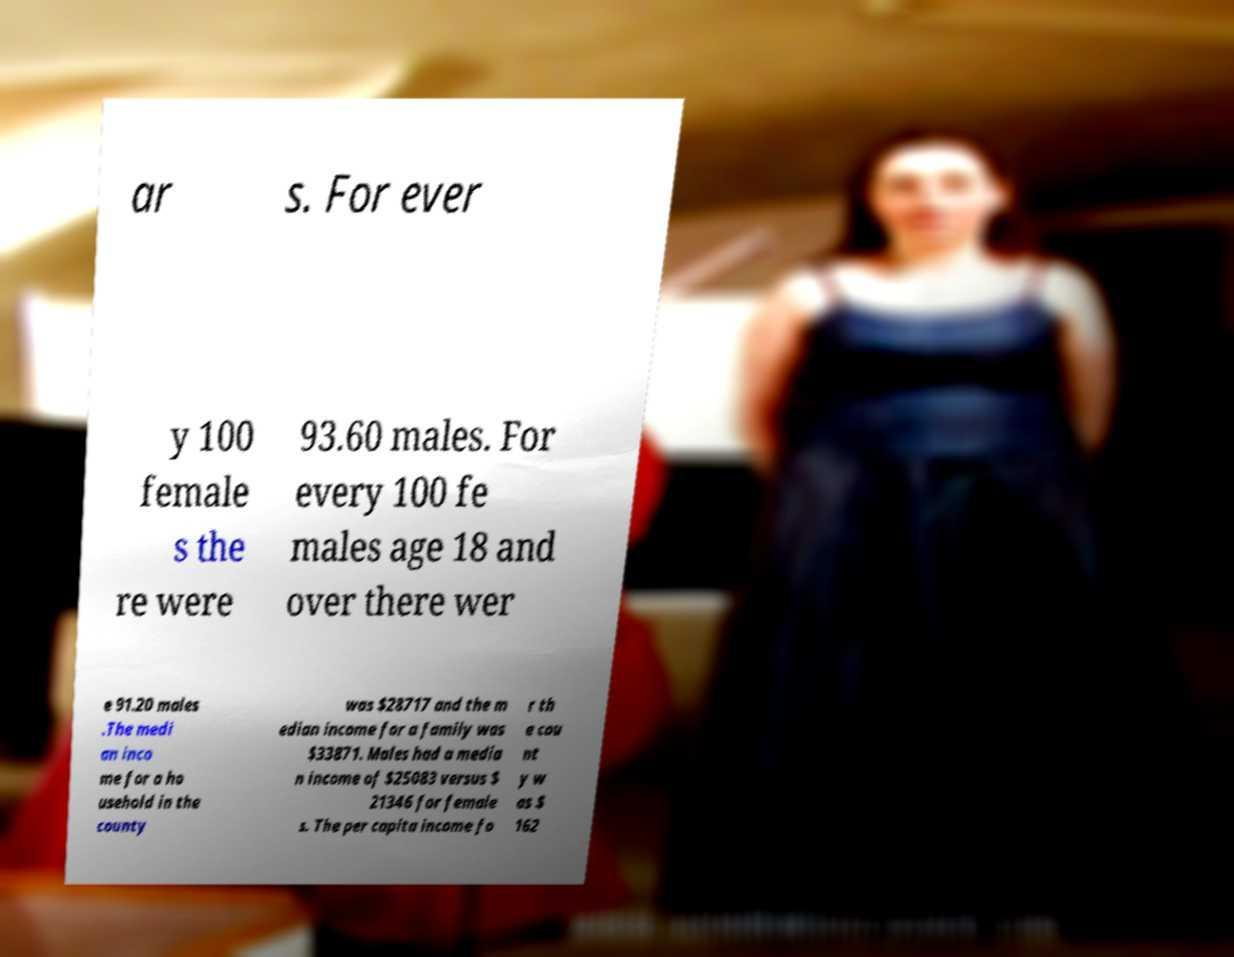Can you read and provide the text displayed in the image?This photo seems to have some interesting text. Can you extract and type it out for me? ar s. For ever y 100 female s the re were 93.60 males. For every 100 fe males age 18 and over there wer e 91.20 males .The medi an inco me for a ho usehold in the county was $28717 and the m edian income for a family was $33871. Males had a media n income of $25083 versus $ 21346 for female s. The per capita income fo r th e cou nt y w as $ 162 